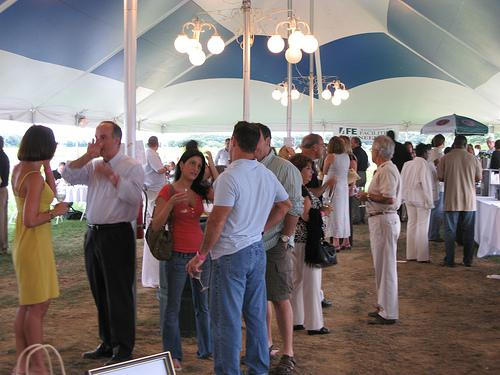Question: what are the people doing?
Choices:
A. Standing and talking.
B. Eating.
C. Swimming.
D. Running.
Answer with the letter. Answer: A Question: who is wearing a yellow dress?
Choices:
A. The young girl.
B. The mannequin.
C. The woman on the left.
D. The model.
Answer with the letter. Answer: C Question: what is on the ground?
Choices:
A. Snow.
B. Dirt.
C. Leaves.
D. Grass.
Answer with the letter. Answer: B 